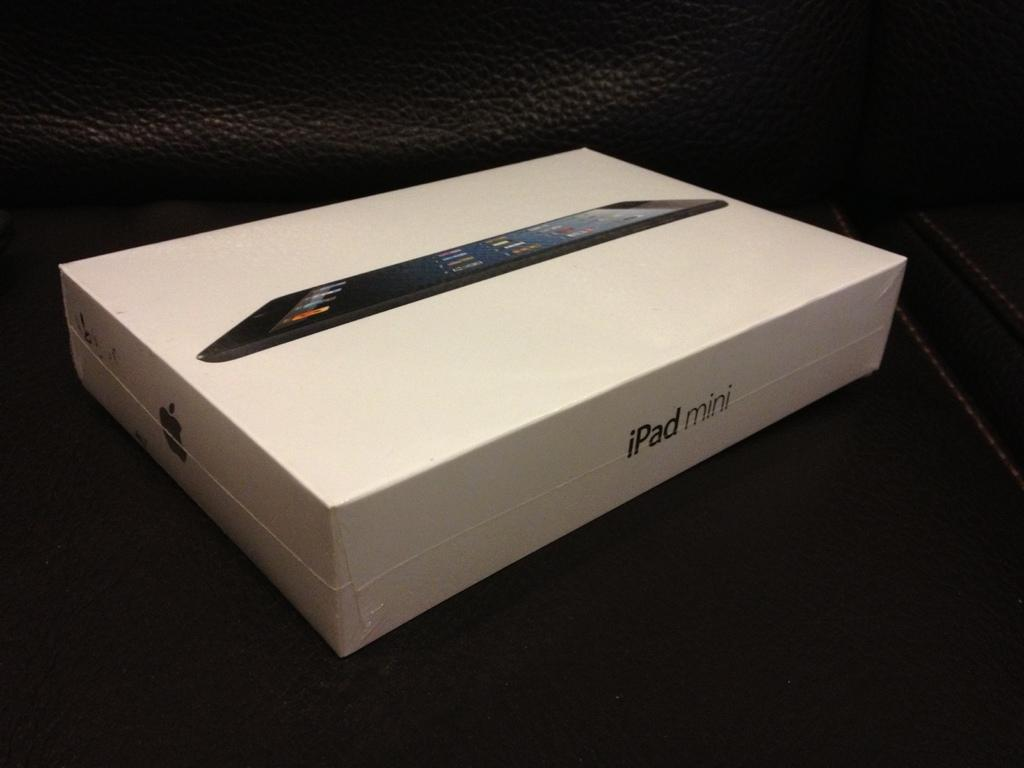What is the color of the surface in the image? The surface in the image is black. What can be seen on the black surface? There is a box with an Apple logo in the image. What is depicted on the box? There is a picture of an iPad on the box. How many trucks are parked at the harbor in the image? There are no trucks or harbor present in the image. Can you tell me how many dinosaurs are visible in the image? There are no dinosaurs present in the image. 